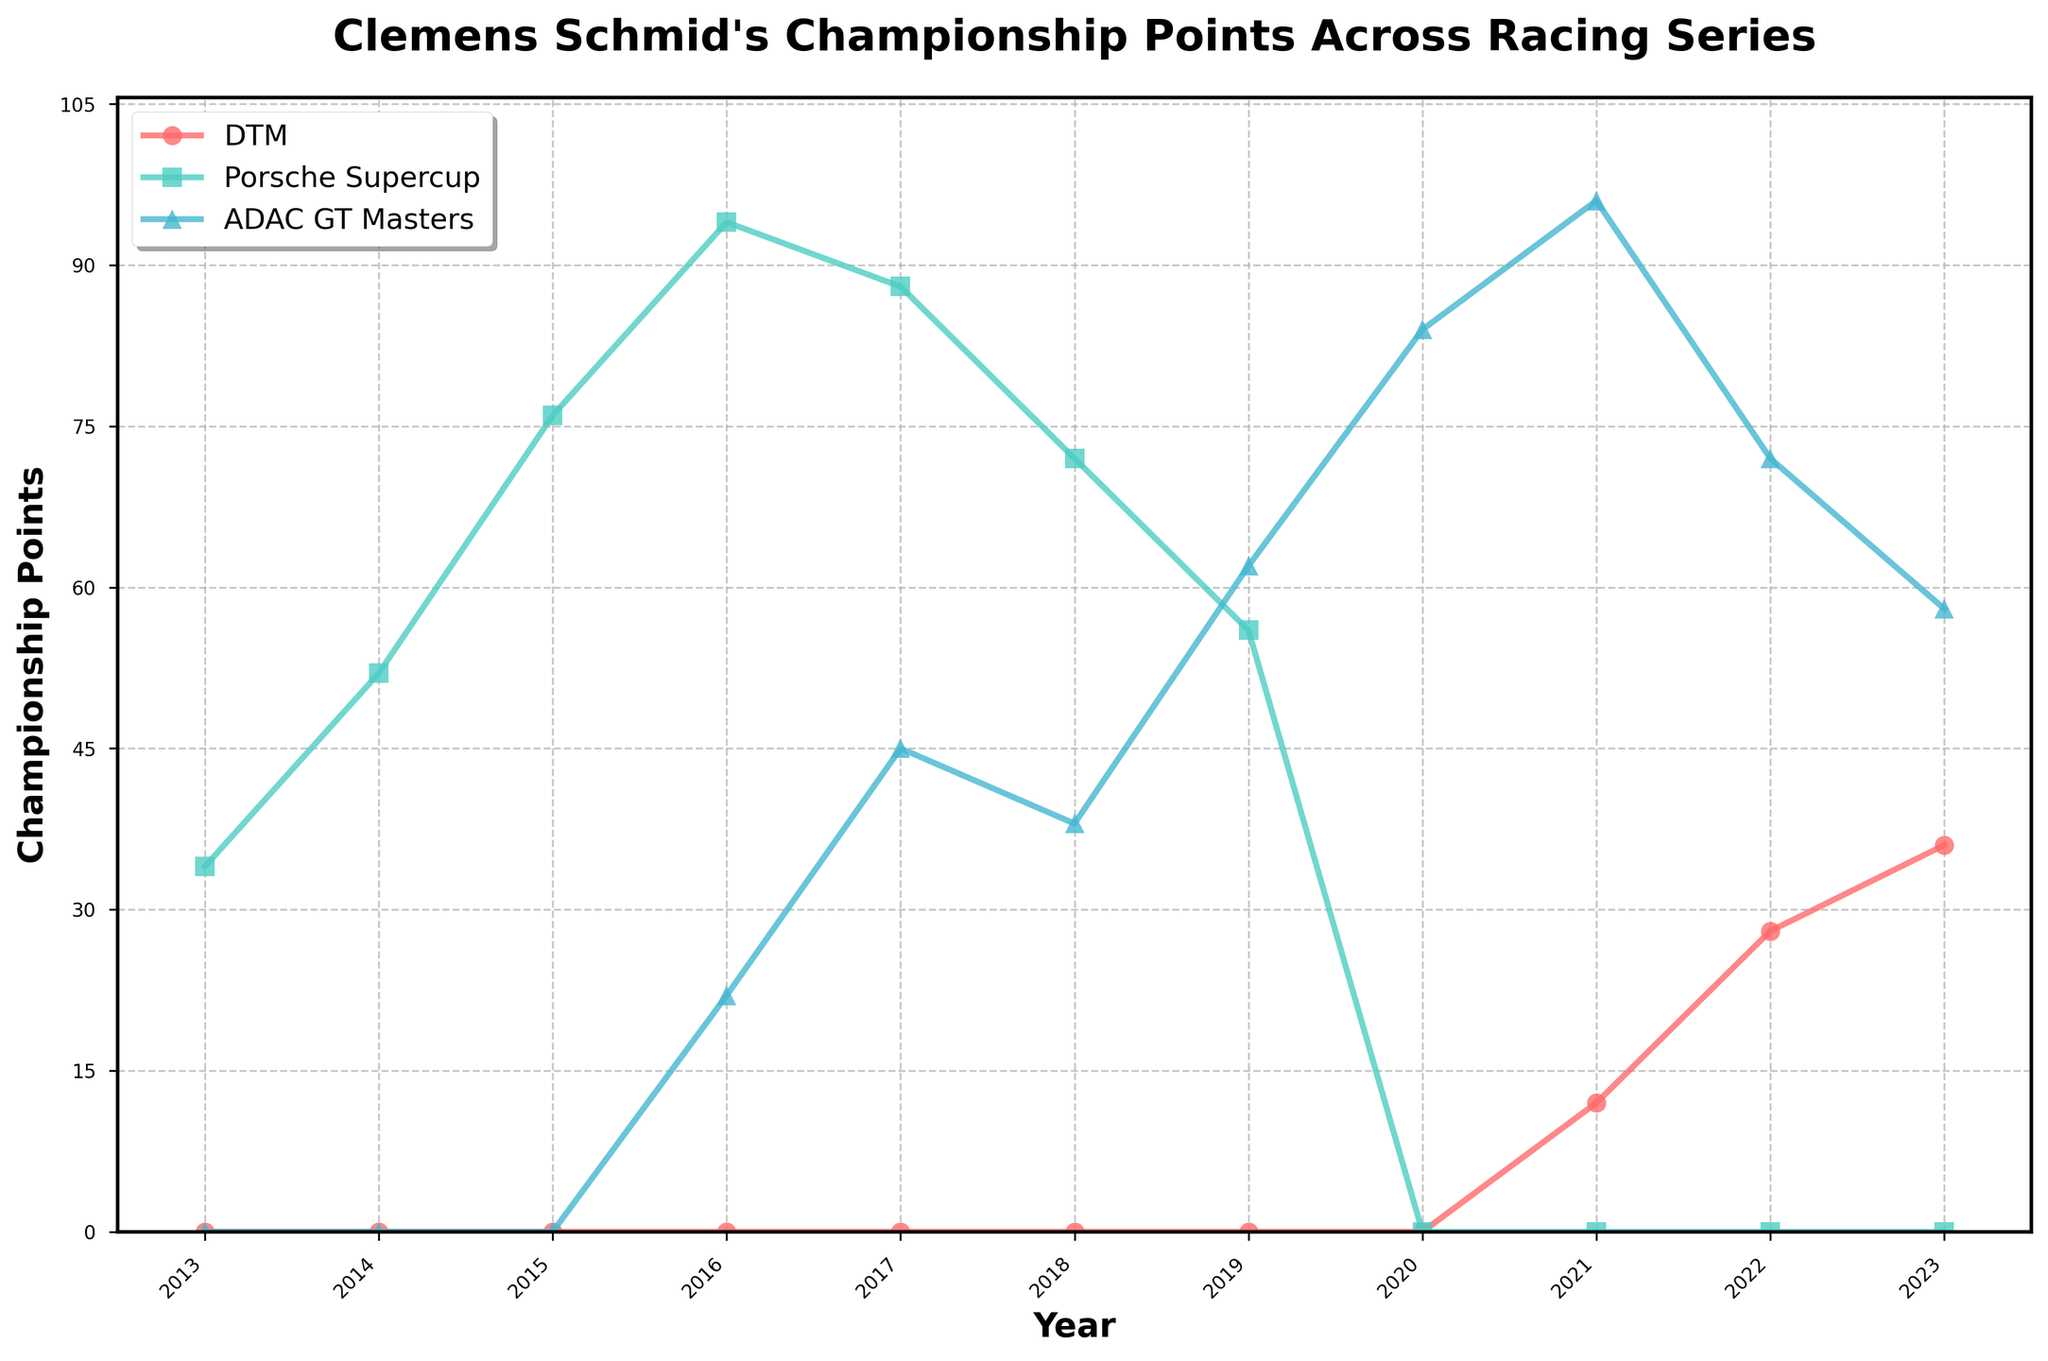Which year did Clemens Schmid achieve the highest championship points in ADAC GT Masters? Look at the ADAC GT Masters line (blue) and identify the peak, which is at 2021 with 96 points.
Answer: 2021 In which season did Clemens Schmid start accumulating points in DTM? Look for the first year with non-zero points in the DTM line (red), which appears in 2021.
Answer: 2021 Compare the championship points for Porsche Supercup in 2016 and 2017. Which year had higher points and by how much? Refer to the Porsche Supercup line (green) and check the points for 2016 (94) and 2017 (88). The points were higher in 2016 by 6.
Answer: 2016 by 6 points What is the total number of championship points Clemens Schmid accumulated in Porsche Supercup? Sum the points for all years in the Porsche Supercup series: 34 + 52 + 76 + 94 + 88 + 72 + 56 = 472.
Answer: 472 In which racing series did Clemens Schmid accumulate more points in 2019, and what is the difference? Compare the values for 2019: DTM (0), Porsche Supercup (56), ADAC GT Masters (62). The difference between ADAC GT Masters and Porsche Supercup is 62 - 56 = 6.
Answer: ADAC GT Masters by 6 points What is the average number of championship points Clemens Schmid achieved in DTM from 2021 to 2023? Sum the DTM points for 2021 (12), 2022 (28), and 2023 (36) and divide by the number of years (3): (12 + 28 + 36) / 3 = 76 / 3 ≈ 25.33.
Answer: Approximately 25.33 Which series shows a stronger upward trend from 2013 to 2016, Porsche Supercup or ADAC GT Masters? Compare both lines: Porsche Supercup goes from 34 to 94, an increase of 60 points. ADAC GT Masters goes from 0 to 22, an increase of 22 points. Porsche Supercup has a stronger upward trend.
Answer: Porsche Supercup What year did Clemens Schmid achieve his highest total championship points across all series combined? Calculate total points for each year and compare them: 
2013: 34, 
2014: 52, 
2015: 76, 
2016: 116 (94+22), 
2017: 133 (88+45), 
2018: 110 (72+38), 
2019: 118 (56+62), 
2020: 84, 
2021: 108 (12+96), 
2022: 100 (28+72), 
2023: 94 (36+58). The highest is 2017 with 133 points.
Answer: 2017 